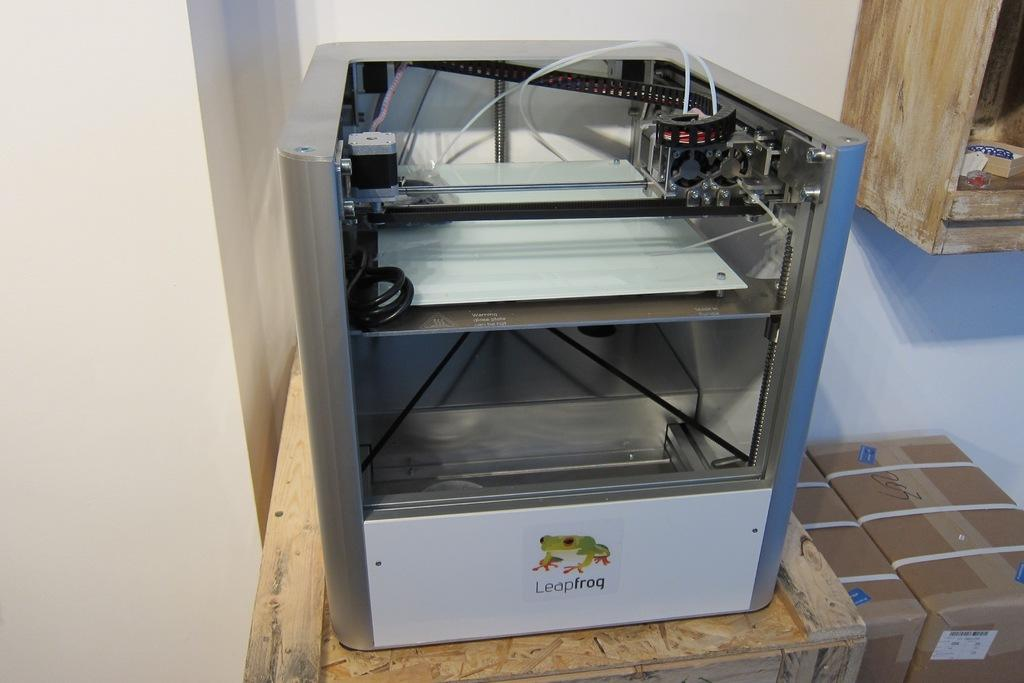What is the color of the wall in the image? The wall in the image is white. What type of furniture is present in the image? There are cupboards in the image. What other objects can be seen in the image? There are boxes and an electrical equipment in the image. Can you see a tramp in the image? No, there is no tramp present in the image. Is there a camera visible in the image? No, there is no camera visible in the image. 